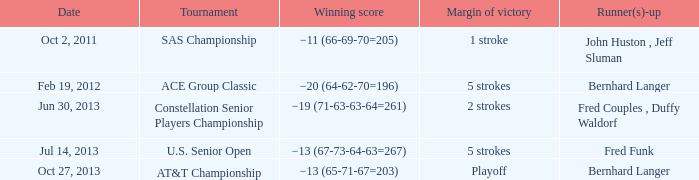Which Date has a Runner(s)-up of bernhard langer, and a Tournament of at&t championship? Oct 27, 2013. 